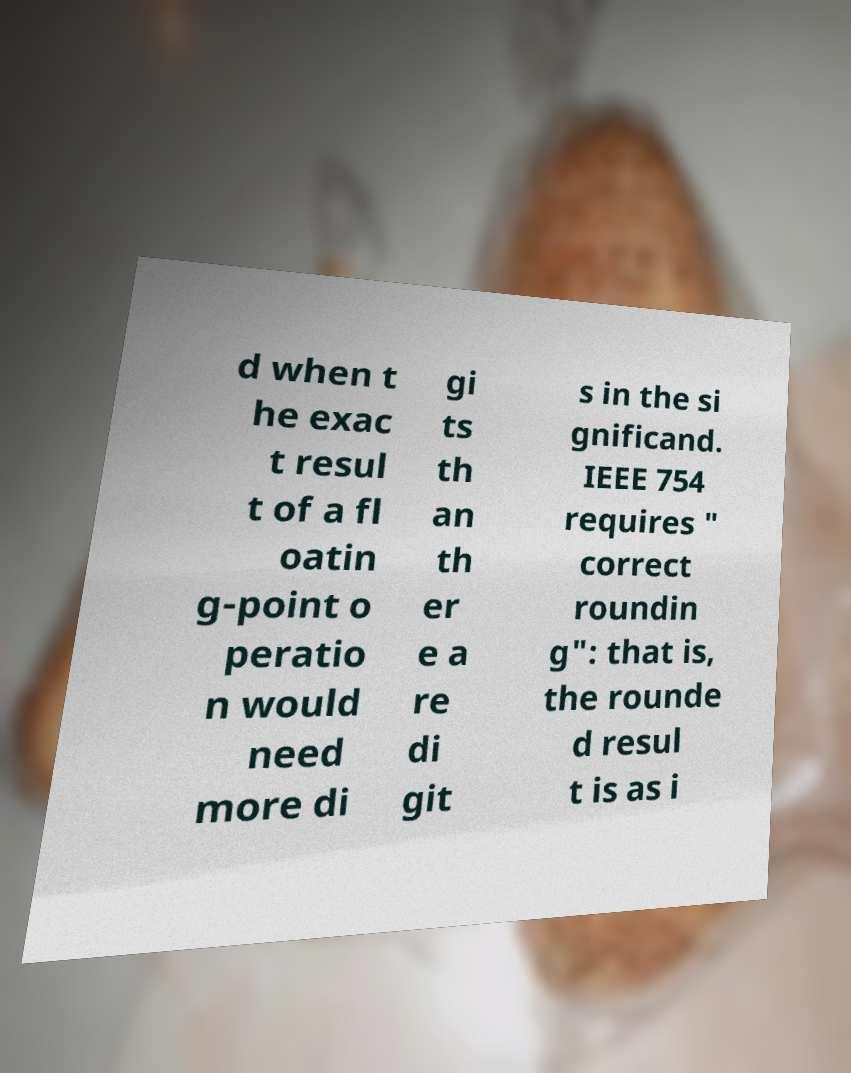What messages or text are displayed in this image? I need them in a readable, typed format. d when t he exac t resul t of a fl oatin g-point o peratio n would need more di gi ts th an th er e a re di git s in the si gnificand. IEEE 754 requires " correct roundin g": that is, the rounde d resul t is as i 